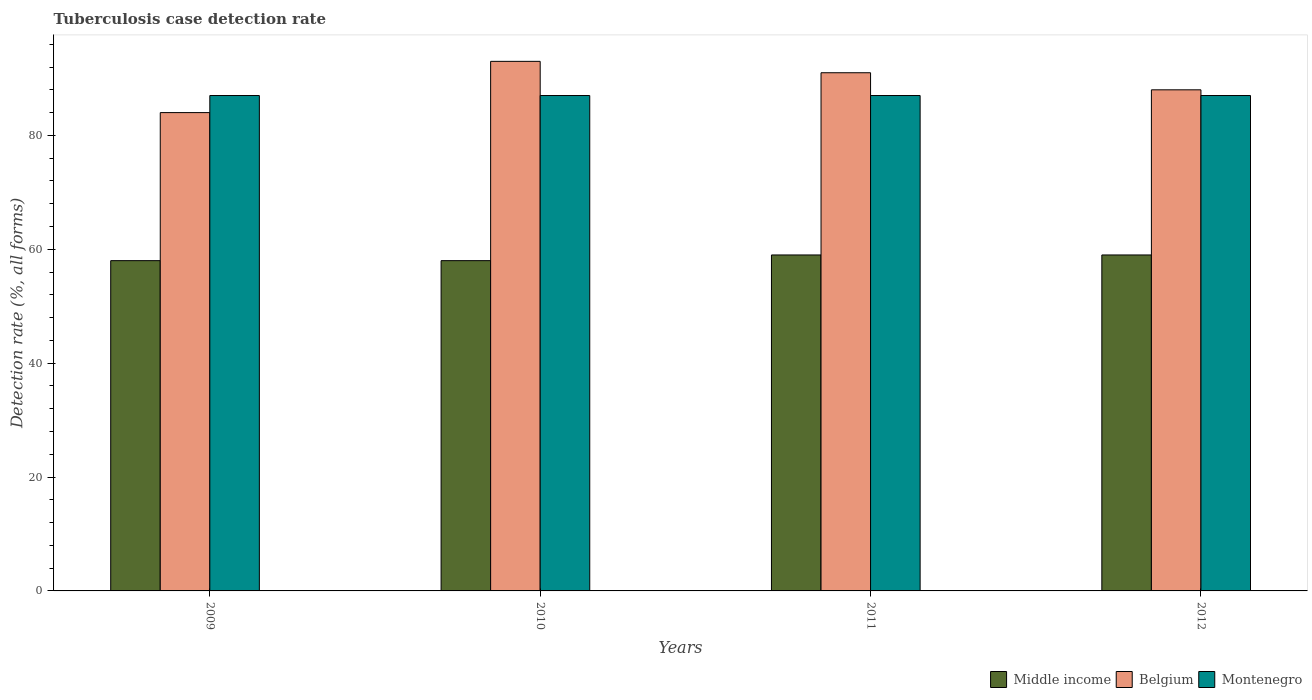Are the number of bars per tick equal to the number of legend labels?
Make the answer very short. Yes. Are the number of bars on each tick of the X-axis equal?
Your answer should be very brief. Yes. How many bars are there on the 4th tick from the left?
Your answer should be very brief. 3. What is the label of the 3rd group of bars from the left?
Make the answer very short. 2011. In how many cases, is the number of bars for a given year not equal to the number of legend labels?
Keep it short and to the point. 0. What is the tuberculosis case detection rate in in Montenegro in 2011?
Your answer should be very brief. 87. Across all years, what is the maximum tuberculosis case detection rate in in Middle income?
Ensure brevity in your answer.  59. Across all years, what is the minimum tuberculosis case detection rate in in Belgium?
Ensure brevity in your answer.  84. In which year was the tuberculosis case detection rate in in Middle income maximum?
Give a very brief answer. 2011. In which year was the tuberculosis case detection rate in in Belgium minimum?
Provide a succinct answer. 2009. What is the total tuberculosis case detection rate in in Middle income in the graph?
Keep it short and to the point. 234. What is the difference between the tuberculosis case detection rate in in Middle income in 2009 and that in 2010?
Keep it short and to the point. 0. What is the average tuberculosis case detection rate in in Belgium per year?
Ensure brevity in your answer.  89. In the year 2009, what is the difference between the tuberculosis case detection rate in in Middle income and tuberculosis case detection rate in in Montenegro?
Your answer should be very brief. -29. Is the tuberculosis case detection rate in in Belgium in 2009 less than that in 2012?
Ensure brevity in your answer.  Yes. Is the difference between the tuberculosis case detection rate in in Middle income in 2011 and 2012 greater than the difference between the tuberculosis case detection rate in in Montenegro in 2011 and 2012?
Provide a short and direct response. No. What is the difference between the highest and the second highest tuberculosis case detection rate in in Belgium?
Give a very brief answer. 2. What is the difference between the highest and the lowest tuberculosis case detection rate in in Montenegro?
Your response must be concise. 0. Is the sum of the tuberculosis case detection rate in in Belgium in 2010 and 2012 greater than the maximum tuberculosis case detection rate in in Montenegro across all years?
Offer a terse response. Yes. What does the 2nd bar from the left in 2009 represents?
Your answer should be very brief. Belgium. How many bars are there?
Your response must be concise. 12. Are the values on the major ticks of Y-axis written in scientific E-notation?
Your answer should be very brief. No. How many legend labels are there?
Offer a very short reply. 3. What is the title of the graph?
Give a very brief answer. Tuberculosis case detection rate. Does "Bolivia" appear as one of the legend labels in the graph?
Ensure brevity in your answer.  No. What is the label or title of the X-axis?
Provide a short and direct response. Years. What is the label or title of the Y-axis?
Provide a short and direct response. Detection rate (%, all forms). What is the Detection rate (%, all forms) in Belgium in 2009?
Offer a terse response. 84. What is the Detection rate (%, all forms) in Montenegro in 2009?
Keep it short and to the point. 87. What is the Detection rate (%, all forms) of Belgium in 2010?
Your response must be concise. 93. What is the Detection rate (%, all forms) in Middle income in 2011?
Give a very brief answer. 59. What is the Detection rate (%, all forms) in Belgium in 2011?
Provide a short and direct response. 91. What is the Detection rate (%, all forms) in Montenegro in 2011?
Your answer should be compact. 87. What is the Detection rate (%, all forms) in Middle income in 2012?
Your answer should be compact. 59. What is the Detection rate (%, all forms) of Montenegro in 2012?
Offer a terse response. 87. Across all years, what is the maximum Detection rate (%, all forms) in Belgium?
Offer a terse response. 93. Across all years, what is the minimum Detection rate (%, all forms) in Belgium?
Offer a terse response. 84. What is the total Detection rate (%, all forms) in Middle income in the graph?
Your response must be concise. 234. What is the total Detection rate (%, all forms) of Belgium in the graph?
Keep it short and to the point. 356. What is the total Detection rate (%, all forms) in Montenegro in the graph?
Ensure brevity in your answer.  348. What is the difference between the Detection rate (%, all forms) in Belgium in 2009 and that in 2010?
Your response must be concise. -9. What is the difference between the Detection rate (%, all forms) in Middle income in 2009 and that in 2011?
Offer a very short reply. -1. What is the difference between the Detection rate (%, all forms) in Belgium in 2009 and that in 2011?
Offer a terse response. -7. What is the difference between the Detection rate (%, all forms) in Middle income in 2009 and that in 2012?
Provide a short and direct response. -1. What is the difference between the Detection rate (%, all forms) of Middle income in 2010 and that in 2011?
Provide a short and direct response. -1. What is the difference between the Detection rate (%, all forms) of Belgium in 2010 and that in 2011?
Give a very brief answer. 2. What is the difference between the Detection rate (%, all forms) of Middle income in 2010 and that in 2012?
Ensure brevity in your answer.  -1. What is the difference between the Detection rate (%, all forms) of Belgium in 2010 and that in 2012?
Offer a very short reply. 5. What is the difference between the Detection rate (%, all forms) of Middle income in 2011 and that in 2012?
Offer a very short reply. 0. What is the difference between the Detection rate (%, all forms) in Belgium in 2011 and that in 2012?
Provide a short and direct response. 3. What is the difference between the Detection rate (%, all forms) in Middle income in 2009 and the Detection rate (%, all forms) in Belgium in 2010?
Give a very brief answer. -35. What is the difference between the Detection rate (%, all forms) of Middle income in 2009 and the Detection rate (%, all forms) of Montenegro in 2010?
Keep it short and to the point. -29. What is the difference between the Detection rate (%, all forms) in Belgium in 2009 and the Detection rate (%, all forms) in Montenegro in 2010?
Offer a terse response. -3. What is the difference between the Detection rate (%, all forms) in Middle income in 2009 and the Detection rate (%, all forms) in Belgium in 2011?
Give a very brief answer. -33. What is the difference between the Detection rate (%, all forms) in Belgium in 2009 and the Detection rate (%, all forms) in Montenegro in 2011?
Offer a very short reply. -3. What is the difference between the Detection rate (%, all forms) of Middle income in 2009 and the Detection rate (%, all forms) of Montenegro in 2012?
Your response must be concise. -29. What is the difference between the Detection rate (%, all forms) of Belgium in 2009 and the Detection rate (%, all forms) of Montenegro in 2012?
Ensure brevity in your answer.  -3. What is the difference between the Detection rate (%, all forms) in Middle income in 2010 and the Detection rate (%, all forms) in Belgium in 2011?
Offer a very short reply. -33. What is the difference between the Detection rate (%, all forms) of Middle income in 2010 and the Detection rate (%, all forms) of Montenegro in 2011?
Offer a terse response. -29. What is the difference between the Detection rate (%, all forms) in Middle income in 2010 and the Detection rate (%, all forms) in Montenegro in 2012?
Your response must be concise. -29. What is the difference between the Detection rate (%, all forms) in Belgium in 2010 and the Detection rate (%, all forms) in Montenegro in 2012?
Ensure brevity in your answer.  6. What is the difference between the Detection rate (%, all forms) in Middle income in 2011 and the Detection rate (%, all forms) in Belgium in 2012?
Your response must be concise. -29. What is the difference between the Detection rate (%, all forms) in Belgium in 2011 and the Detection rate (%, all forms) in Montenegro in 2012?
Your response must be concise. 4. What is the average Detection rate (%, all forms) of Middle income per year?
Provide a short and direct response. 58.5. What is the average Detection rate (%, all forms) in Belgium per year?
Offer a terse response. 89. What is the average Detection rate (%, all forms) in Montenegro per year?
Your response must be concise. 87. In the year 2009, what is the difference between the Detection rate (%, all forms) of Middle income and Detection rate (%, all forms) of Belgium?
Provide a short and direct response. -26. In the year 2009, what is the difference between the Detection rate (%, all forms) of Middle income and Detection rate (%, all forms) of Montenegro?
Give a very brief answer. -29. In the year 2010, what is the difference between the Detection rate (%, all forms) of Middle income and Detection rate (%, all forms) of Belgium?
Your answer should be compact. -35. In the year 2010, what is the difference between the Detection rate (%, all forms) in Middle income and Detection rate (%, all forms) in Montenegro?
Your answer should be very brief. -29. In the year 2010, what is the difference between the Detection rate (%, all forms) of Belgium and Detection rate (%, all forms) of Montenegro?
Offer a very short reply. 6. In the year 2011, what is the difference between the Detection rate (%, all forms) of Middle income and Detection rate (%, all forms) of Belgium?
Your answer should be compact. -32. In the year 2011, what is the difference between the Detection rate (%, all forms) of Middle income and Detection rate (%, all forms) of Montenegro?
Provide a succinct answer. -28. In the year 2012, what is the difference between the Detection rate (%, all forms) in Middle income and Detection rate (%, all forms) in Belgium?
Give a very brief answer. -29. In the year 2012, what is the difference between the Detection rate (%, all forms) of Belgium and Detection rate (%, all forms) of Montenegro?
Your answer should be compact. 1. What is the ratio of the Detection rate (%, all forms) of Middle income in 2009 to that in 2010?
Provide a short and direct response. 1. What is the ratio of the Detection rate (%, all forms) of Belgium in 2009 to that in 2010?
Keep it short and to the point. 0.9. What is the ratio of the Detection rate (%, all forms) of Montenegro in 2009 to that in 2010?
Provide a succinct answer. 1. What is the ratio of the Detection rate (%, all forms) of Middle income in 2009 to that in 2011?
Your response must be concise. 0.98. What is the ratio of the Detection rate (%, all forms) of Belgium in 2009 to that in 2011?
Your response must be concise. 0.92. What is the ratio of the Detection rate (%, all forms) of Middle income in 2009 to that in 2012?
Give a very brief answer. 0.98. What is the ratio of the Detection rate (%, all forms) of Belgium in 2009 to that in 2012?
Offer a very short reply. 0.95. What is the ratio of the Detection rate (%, all forms) in Middle income in 2010 to that in 2011?
Your answer should be compact. 0.98. What is the ratio of the Detection rate (%, all forms) in Belgium in 2010 to that in 2011?
Ensure brevity in your answer.  1.02. What is the ratio of the Detection rate (%, all forms) of Middle income in 2010 to that in 2012?
Make the answer very short. 0.98. What is the ratio of the Detection rate (%, all forms) in Belgium in 2010 to that in 2012?
Offer a terse response. 1.06. What is the ratio of the Detection rate (%, all forms) of Middle income in 2011 to that in 2012?
Keep it short and to the point. 1. What is the ratio of the Detection rate (%, all forms) in Belgium in 2011 to that in 2012?
Give a very brief answer. 1.03. What is the difference between the highest and the second highest Detection rate (%, all forms) of Middle income?
Your response must be concise. 0. What is the difference between the highest and the second highest Detection rate (%, all forms) in Belgium?
Provide a succinct answer. 2. What is the difference between the highest and the second highest Detection rate (%, all forms) in Montenegro?
Your answer should be very brief. 0. What is the difference between the highest and the lowest Detection rate (%, all forms) in Middle income?
Ensure brevity in your answer.  1. What is the difference between the highest and the lowest Detection rate (%, all forms) of Belgium?
Keep it short and to the point. 9. What is the difference between the highest and the lowest Detection rate (%, all forms) in Montenegro?
Give a very brief answer. 0. 